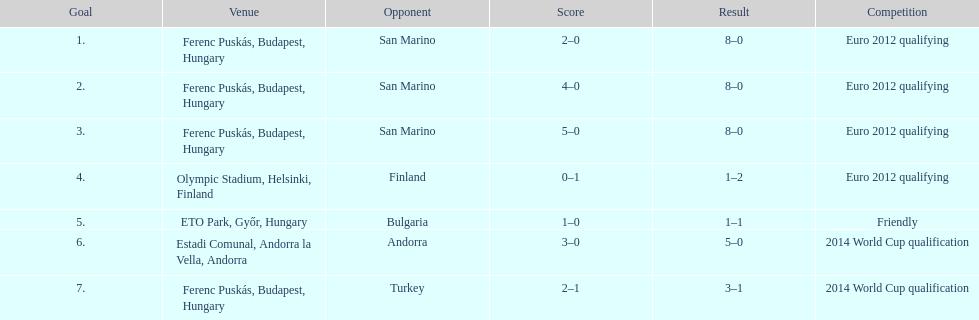What year was it when ádám szalai netted his next international goal after 2010? 2012. 